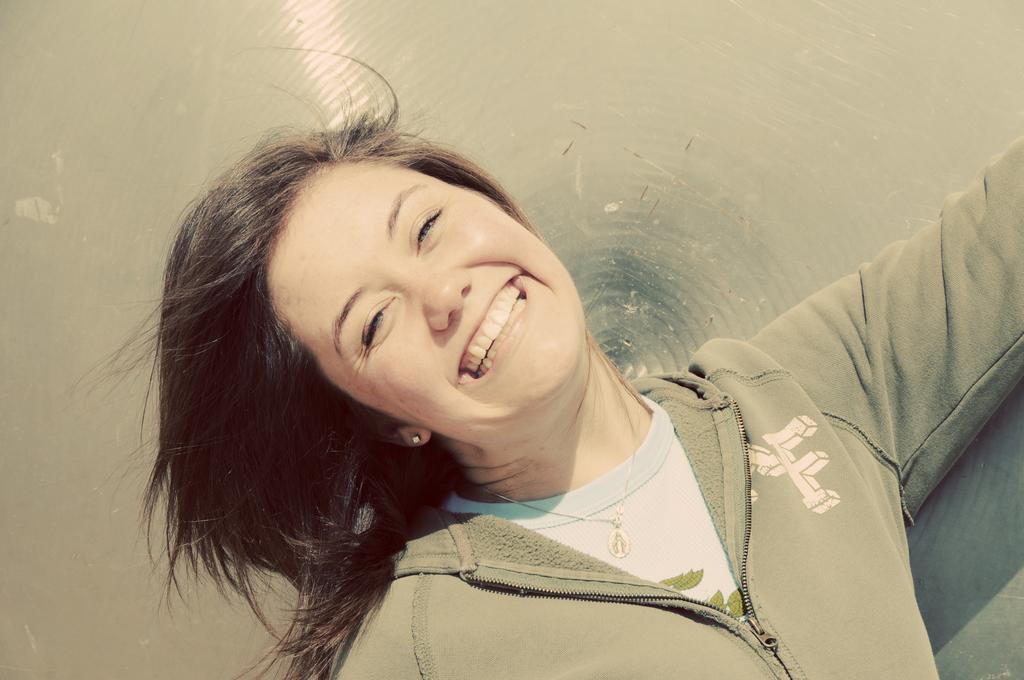Can you describe this image briefly? In this picture we can see a close view of the girl wearing a green jacket, standing in the front smiling and giving a pose to the camera. 